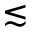<formula> <loc_0><loc_0><loc_500><loc_500>\lesssim</formula> 